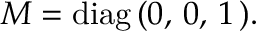Convert formula to latex. <formula><loc_0><loc_0><loc_500><loc_500>M = d i a g \, ( 0 , \, 0 , \, 1 \, ) .</formula> 